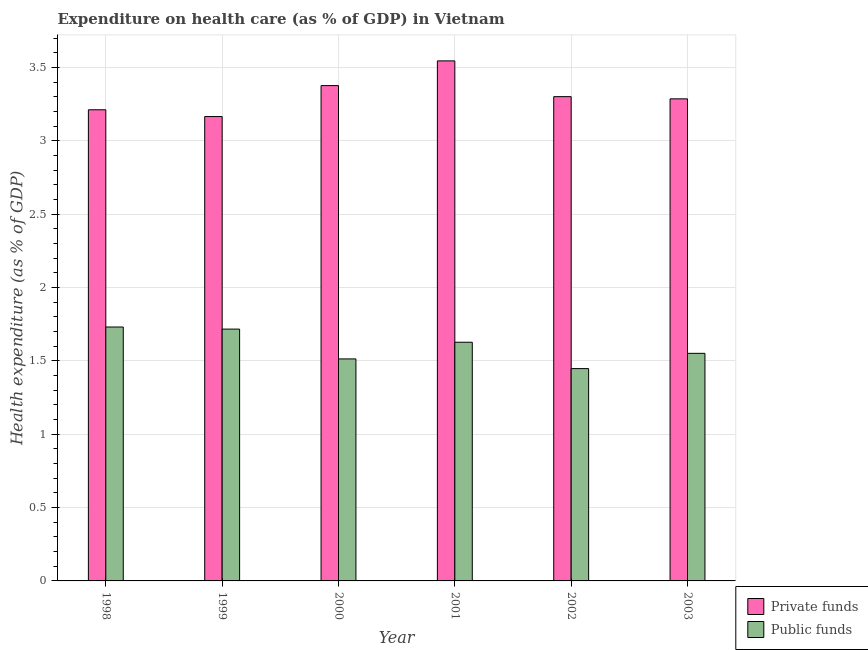How many groups of bars are there?
Your answer should be very brief. 6. Are the number of bars per tick equal to the number of legend labels?
Make the answer very short. Yes. Are the number of bars on each tick of the X-axis equal?
Provide a succinct answer. Yes. How many bars are there on the 2nd tick from the left?
Your answer should be compact. 2. What is the label of the 4th group of bars from the left?
Make the answer very short. 2001. What is the amount of private funds spent in healthcare in 2002?
Make the answer very short. 3.3. Across all years, what is the maximum amount of private funds spent in healthcare?
Your answer should be compact. 3.55. Across all years, what is the minimum amount of public funds spent in healthcare?
Your response must be concise. 1.45. In which year was the amount of public funds spent in healthcare maximum?
Your response must be concise. 1998. What is the total amount of public funds spent in healthcare in the graph?
Offer a very short reply. 9.59. What is the difference between the amount of public funds spent in healthcare in 1998 and that in 2000?
Offer a terse response. 0.22. What is the difference between the amount of private funds spent in healthcare in 2000 and the amount of public funds spent in healthcare in 2001?
Give a very brief answer. -0.17. What is the average amount of private funds spent in healthcare per year?
Your answer should be very brief. 3.32. What is the ratio of the amount of private funds spent in healthcare in 1998 to that in 2003?
Offer a very short reply. 0.98. Is the amount of private funds spent in healthcare in 2001 less than that in 2002?
Make the answer very short. No. Is the difference between the amount of public funds spent in healthcare in 2001 and 2002 greater than the difference between the amount of private funds spent in healthcare in 2001 and 2002?
Provide a short and direct response. No. What is the difference between the highest and the second highest amount of public funds spent in healthcare?
Ensure brevity in your answer.  0.01. What is the difference between the highest and the lowest amount of private funds spent in healthcare?
Offer a very short reply. 0.38. In how many years, is the amount of private funds spent in healthcare greater than the average amount of private funds spent in healthcare taken over all years?
Your response must be concise. 2. Is the sum of the amount of public funds spent in healthcare in 1999 and 2000 greater than the maximum amount of private funds spent in healthcare across all years?
Your answer should be compact. Yes. What does the 1st bar from the left in 2001 represents?
Offer a terse response. Private funds. What does the 1st bar from the right in 2000 represents?
Provide a succinct answer. Public funds. How many bars are there?
Make the answer very short. 12. Are the values on the major ticks of Y-axis written in scientific E-notation?
Keep it short and to the point. No. Where does the legend appear in the graph?
Your response must be concise. Bottom right. How are the legend labels stacked?
Your answer should be compact. Vertical. What is the title of the graph?
Your answer should be compact. Expenditure on health care (as % of GDP) in Vietnam. Does "Infant" appear as one of the legend labels in the graph?
Provide a short and direct response. No. What is the label or title of the X-axis?
Give a very brief answer. Year. What is the label or title of the Y-axis?
Keep it short and to the point. Health expenditure (as % of GDP). What is the Health expenditure (as % of GDP) of Private funds in 1998?
Provide a short and direct response. 3.21. What is the Health expenditure (as % of GDP) in Public funds in 1998?
Offer a very short reply. 1.73. What is the Health expenditure (as % of GDP) of Private funds in 1999?
Keep it short and to the point. 3.17. What is the Health expenditure (as % of GDP) in Public funds in 1999?
Give a very brief answer. 1.72. What is the Health expenditure (as % of GDP) of Private funds in 2000?
Your response must be concise. 3.38. What is the Health expenditure (as % of GDP) in Public funds in 2000?
Provide a succinct answer. 1.51. What is the Health expenditure (as % of GDP) of Private funds in 2001?
Ensure brevity in your answer.  3.55. What is the Health expenditure (as % of GDP) of Public funds in 2001?
Offer a very short reply. 1.63. What is the Health expenditure (as % of GDP) of Private funds in 2002?
Provide a succinct answer. 3.3. What is the Health expenditure (as % of GDP) in Public funds in 2002?
Provide a succinct answer. 1.45. What is the Health expenditure (as % of GDP) in Private funds in 2003?
Keep it short and to the point. 3.29. What is the Health expenditure (as % of GDP) in Public funds in 2003?
Give a very brief answer. 1.55. Across all years, what is the maximum Health expenditure (as % of GDP) of Private funds?
Ensure brevity in your answer.  3.55. Across all years, what is the maximum Health expenditure (as % of GDP) of Public funds?
Offer a very short reply. 1.73. Across all years, what is the minimum Health expenditure (as % of GDP) of Private funds?
Provide a succinct answer. 3.17. Across all years, what is the minimum Health expenditure (as % of GDP) in Public funds?
Provide a succinct answer. 1.45. What is the total Health expenditure (as % of GDP) of Private funds in the graph?
Give a very brief answer. 19.89. What is the total Health expenditure (as % of GDP) of Public funds in the graph?
Ensure brevity in your answer.  9.59. What is the difference between the Health expenditure (as % of GDP) in Private funds in 1998 and that in 1999?
Offer a very short reply. 0.05. What is the difference between the Health expenditure (as % of GDP) of Public funds in 1998 and that in 1999?
Your response must be concise. 0.01. What is the difference between the Health expenditure (as % of GDP) of Private funds in 1998 and that in 2000?
Provide a succinct answer. -0.16. What is the difference between the Health expenditure (as % of GDP) in Public funds in 1998 and that in 2000?
Provide a succinct answer. 0.22. What is the difference between the Health expenditure (as % of GDP) in Private funds in 1998 and that in 2001?
Your answer should be compact. -0.33. What is the difference between the Health expenditure (as % of GDP) in Public funds in 1998 and that in 2001?
Keep it short and to the point. 0.1. What is the difference between the Health expenditure (as % of GDP) in Private funds in 1998 and that in 2002?
Ensure brevity in your answer.  -0.09. What is the difference between the Health expenditure (as % of GDP) in Public funds in 1998 and that in 2002?
Give a very brief answer. 0.28. What is the difference between the Health expenditure (as % of GDP) in Private funds in 1998 and that in 2003?
Your answer should be very brief. -0.07. What is the difference between the Health expenditure (as % of GDP) in Public funds in 1998 and that in 2003?
Your answer should be very brief. 0.18. What is the difference between the Health expenditure (as % of GDP) in Private funds in 1999 and that in 2000?
Offer a terse response. -0.21. What is the difference between the Health expenditure (as % of GDP) in Public funds in 1999 and that in 2000?
Provide a short and direct response. 0.2. What is the difference between the Health expenditure (as % of GDP) of Private funds in 1999 and that in 2001?
Make the answer very short. -0.38. What is the difference between the Health expenditure (as % of GDP) of Public funds in 1999 and that in 2001?
Ensure brevity in your answer.  0.09. What is the difference between the Health expenditure (as % of GDP) of Private funds in 1999 and that in 2002?
Provide a succinct answer. -0.14. What is the difference between the Health expenditure (as % of GDP) in Public funds in 1999 and that in 2002?
Offer a very short reply. 0.27. What is the difference between the Health expenditure (as % of GDP) of Private funds in 1999 and that in 2003?
Offer a terse response. -0.12. What is the difference between the Health expenditure (as % of GDP) of Public funds in 1999 and that in 2003?
Give a very brief answer. 0.17. What is the difference between the Health expenditure (as % of GDP) in Private funds in 2000 and that in 2001?
Provide a succinct answer. -0.17. What is the difference between the Health expenditure (as % of GDP) in Public funds in 2000 and that in 2001?
Offer a very short reply. -0.11. What is the difference between the Health expenditure (as % of GDP) in Private funds in 2000 and that in 2002?
Ensure brevity in your answer.  0.08. What is the difference between the Health expenditure (as % of GDP) in Public funds in 2000 and that in 2002?
Give a very brief answer. 0.07. What is the difference between the Health expenditure (as % of GDP) in Private funds in 2000 and that in 2003?
Your answer should be compact. 0.09. What is the difference between the Health expenditure (as % of GDP) of Public funds in 2000 and that in 2003?
Ensure brevity in your answer.  -0.04. What is the difference between the Health expenditure (as % of GDP) of Private funds in 2001 and that in 2002?
Your answer should be very brief. 0.24. What is the difference between the Health expenditure (as % of GDP) of Public funds in 2001 and that in 2002?
Give a very brief answer. 0.18. What is the difference between the Health expenditure (as % of GDP) in Private funds in 2001 and that in 2003?
Offer a terse response. 0.26. What is the difference between the Health expenditure (as % of GDP) of Public funds in 2001 and that in 2003?
Your response must be concise. 0.08. What is the difference between the Health expenditure (as % of GDP) in Private funds in 2002 and that in 2003?
Your answer should be very brief. 0.01. What is the difference between the Health expenditure (as % of GDP) in Public funds in 2002 and that in 2003?
Provide a short and direct response. -0.1. What is the difference between the Health expenditure (as % of GDP) of Private funds in 1998 and the Health expenditure (as % of GDP) of Public funds in 1999?
Provide a succinct answer. 1.5. What is the difference between the Health expenditure (as % of GDP) in Private funds in 1998 and the Health expenditure (as % of GDP) in Public funds in 2000?
Give a very brief answer. 1.7. What is the difference between the Health expenditure (as % of GDP) of Private funds in 1998 and the Health expenditure (as % of GDP) of Public funds in 2001?
Offer a terse response. 1.59. What is the difference between the Health expenditure (as % of GDP) in Private funds in 1998 and the Health expenditure (as % of GDP) in Public funds in 2002?
Your answer should be very brief. 1.76. What is the difference between the Health expenditure (as % of GDP) in Private funds in 1998 and the Health expenditure (as % of GDP) in Public funds in 2003?
Offer a very short reply. 1.66. What is the difference between the Health expenditure (as % of GDP) in Private funds in 1999 and the Health expenditure (as % of GDP) in Public funds in 2000?
Ensure brevity in your answer.  1.65. What is the difference between the Health expenditure (as % of GDP) in Private funds in 1999 and the Health expenditure (as % of GDP) in Public funds in 2001?
Provide a succinct answer. 1.54. What is the difference between the Health expenditure (as % of GDP) in Private funds in 1999 and the Health expenditure (as % of GDP) in Public funds in 2002?
Your answer should be very brief. 1.72. What is the difference between the Health expenditure (as % of GDP) in Private funds in 1999 and the Health expenditure (as % of GDP) in Public funds in 2003?
Provide a succinct answer. 1.61. What is the difference between the Health expenditure (as % of GDP) in Private funds in 2000 and the Health expenditure (as % of GDP) in Public funds in 2001?
Give a very brief answer. 1.75. What is the difference between the Health expenditure (as % of GDP) of Private funds in 2000 and the Health expenditure (as % of GDP) of Public funds in 2002?
Provide a succinct answer. 1.93. What is the difference between the Health expenditure (as % of GDP) of Private funds in 2000 and the Health expenditure (as % of GDP) of Public funds in 2003?
Your answer should be compact. 1.83. What is the difference between the Health expenditure (as % of GDP) of Private funds in 2001 and the Health expenditure (as % of GDP) of Public funds in 2002?
Keep it short and to the point. 2.1. What is the difference between the Health expenditure (as % of GDP) of Private funds in 2001 and the Health expenditure (as % of GDP) of Public funds in 2003?
Ensure brevity in your answer.  1.99. What is the difference between the Health expenditure (as % of GDP) of Private funds in 2002 and the Health expenditure (as % of GDP) of Public funds in 2003?
Keep it short and to the point. 1.75. What is the average Health expenditure (as % of GDP) of Private funds per year?
Provide a short and direct response. 3.32. What is the average Health expenditure (as % of GDP) in Public funds per year?
Ensure brevity in your answer.  1.6. In the year 1998, what is the difference between the Health expenditure (as % of GDP) of Private funds and Health expenditure (as % of GDP) of Public funds?
Your answer should be very brief. 1.48. In the year 1999, what is the difference between the Health expenditure (as % of GDP) of Private funds and Health expenditure (as % of GDP) of Public funds?
Ensure brevity in your answer.  1.45. In the year 2000, what is the difference between the Health expenditure (as % of GDP) of Private funds and Health expenditure (as % of GDP) of Public funds?
Ensure brevity in your answer.  1.86. In the year 2001, what is the difference between the Health expenditure (as % of GDP) of Private funds and Health expenditure (as % of GDP) of Public funds?
Offer a terse response. 1.92. In the year 2002, what is the difference between the Health expenditure (as % of GDP) of Private funds and Health expenditure (as % of GDP) of Public funds?
Give a very brief answer. 1.85. In the year 2003, what is the difference between the Health expenditure (as % of GDP) in Private funds and Health expenditure (as % of GDP) in Public funds?
Give a very brief answer. 1.74. What is the ratio of the Health expenditure (as % of GDP) of Private funds in 1998 to that in 1999?
Your response must be concise. 1.01. What is the ratio of the Health expenditure (as % of GDP) in Public funds in 1998 to that in 1999?
Offer a very short reply. 1.01. What is the ratio of the Health expenditure (as % of GDP) in Private funds in 1998 to that in 2000?
Give a very brief answer. 0.95. What is the ratio of the Health expenditure (as % of GDP) of Public funds in 1998 to that in 2000?
Offer a very short reply. 1.14. What is the ratio of the Health expenditure (as % of GDP) in Private funds in 1998 to that in 2001?
Keep it short and to the point. 0.91. What is the ratio of the Health expenditure (as % of GDP) in Public funds in 1998 to that in 2001?
Keep it short and to the point. 1.06. What is the ratio of the Health expenditure (as % of GDP) of Private funds in 1998 to that in 2002?
Offer a terse response. 0.97. What is the ratio of the Health expenditure (as % of GDP) of Public funds in 1998 to that in 2002?
Your response must be concise. 1.2. What is the ratio of the Health expenditure (as % of GDP) in Private funds in 1998 to that in 2003?
Keep it short and to the point. 0.98. What is the ratio of the Health expenditure (as % of GDP) in Public funds in 1998 to that in 2003?
Offer a terse response. 1.12. What is the ratio of the Health expenditure (as % of GDP) of Private funds in 1999 to that in 2000?
Make the answer very short. 0.94. What is the ratio of the Health expenditure (as % of GDP) of Public funds in 1999 to that in 2000?
Your response must be concise. 1.13. What is the ratio of the Health expenditure (as % of GDP) in Private funds in 1999 to that in 2001?
Keep it short and to the point. 0.89. What is the ratio of the Health expenditure (as % of GDP) of Public funds in 1999 to that in 2001?
Give a very brief answer. 1.05. What is the ratio of the Health expenditure (as % of GDP) in Private funds in 1999 to that in 2002?
Keep it short and to the point. 0.96. What is the ratio of the Health expenditure (as % of GDP) in Public funds in 1999 to that in 2002?
Give a very brief answer. 1.19. What is the ratio of the Health expenditure (as % of GDP) in Private funds in 1999 to that in 2003?
Offer a very short reply. 0.96. What is the ratio of the Health expenditure (as % of GDP) in Public funds in 1999 to that in 2003?
Ensure brevity in your answer.  1.11. What is the ratio of the Health expenditure (as % of GDP) in Private funds in 2000 to that in 2001?
Keep it short and to the point. 0.95. What is the ratio of the Health expenditure (as % of GDP) of Public funds in 2000 to that in 2001?
Provide a succinct answer. 0.93. What is the ratio of the Health expenditure (as % of GDP) in Private funds in 2000 to that in 2002?
Your answer should be compact. 1.02. What is the ratio of the Health expenditure (as % of GDP) of Public funds in 2000 to that in 2002?
Provide a short and direct response. 1.05. What is the ratio of the Health expenditure (as % of GDP) of Private funds in 2000 to that in 2003?
Offer a terse response. 1.03. What is the ratio of the Health expenditure (as % of GDP) in Public funds in 2000 to that in 2003?
Keep it short and to the point. 0.98. What is the ratio of the Health expenditure (as % of GDP) of Private funds in 2001 to that in 2002?
Provide a succinct answer. 1.07. What is the ratio of the Health expenditure (as % of GDP) in Public funds in 2001 to that in 2002?
Keep it short and to the point. 1.12. What is the ratio of the Health expenditure (as % of GDP) of Private funds in 2001 to that in 2003?
Give a very brief answer. 1.08. What is the ratio of the Health expenditure (as % of GDP) of Public funds in 2001 to that in 2003?
Give a very brief answer. 1.05. What is the ratio of the Health expenditure (as % of GDP) of Public funds in 2002 to that in 2003?
Offer a terse response. 0.93. What is the difference between the highest and the second highest Health expenditure (as % of GDP) in Private funds?
Offer a terse response. 0.17. What is the difference between the highest and the second highest Health expenditure (as % of GDP) in Public funds?
Provide a short and direct response. 0.01. What is the difference between the highest and the lowest Health expenditure (as % of GDP) of Private funds?
Provide a short and direct response. 0.38. What is the difference between the highest and the lowest Health expenditure (as % of GDP) in Public funds?
Provide a short and direct response. 0.28. 